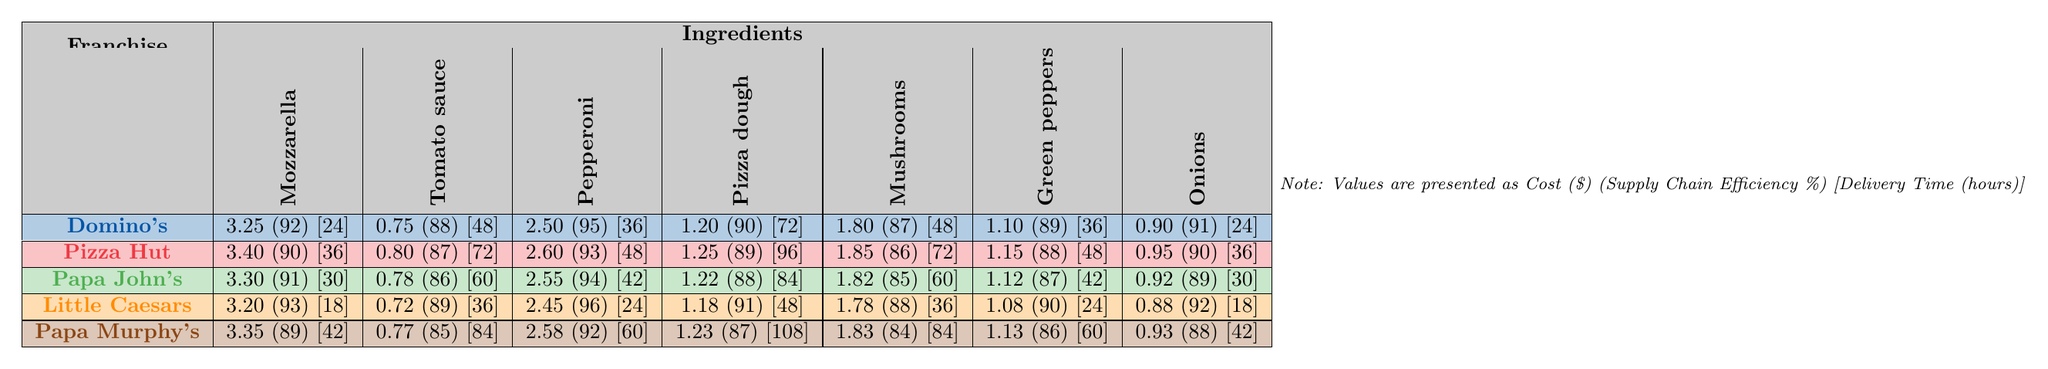What is the cost of mozzarella cheese from Domino's? The table shows the cost of mozzarella cheese for each franchise. For Domino's, the cost is listed as 3.25.
Answer: 3.25 Which franchise has the highest supply chain efficiency for green peppers? The table provides supply chain efficiency percentages for green peppers. Checking the values, Little Caesars has the highest supply chain efficiency at 90%.
Answer: Little Caesars What are the average costs of pizza dough across all franchises? To find the average cost of pizza dough, sum the costs listed (1.20 + 1.25 + 1.22 + 1.18 + 1.23 = 6.08) and divide by the number of franchises (5). Thus, 6.08 / 5 = 1.216.
Answer: 1.216 Is the delivery time for Papa Murphy's shorter than for Papa John's? The delivery times for both franchises can be compared from the table. Papa Murphy's has a delivery time of 42 hours and Papa John's has 30 hours. Since 42 is greater than 30, the statement is false.
Answer: No What is the combined cost of mushrooms and onions from Pizza Hut? From the table, the cost of mushrooms from Pizza Hut is 1.85 and onions is 0.95. Adding these costs together (1.85 + 0.95 = 2.80) gives the combined cost.
Answer: 2.80 Which franchise has the lowest cost for pepperoni? The table indicates that Little Caesars has the lowest cost for pepperoni, priced at 2.45.
Answer: Little Caesars What is the difference in delivery time between the franchise with the shortest and the longest delivery times? Observing the table, the shortest delivery time is 18 hours (Little Caesars) and the longest is 108 hours (Papa Murphy's). The difference is calculated as 108 - 18 = 90 hours.
Answer: 90 Does Domino's have the highest supply chain efficiency for any ingredient? By examining the supply chain efficiency values in the table, Domino's does not have the highest value for any ingredient.
Answer: No What is the average delivery time across all franchises? The delivery times for each franchise are summed (24 + 36 + 30 + 18 + 42 = 150) and then averaged by dividing by 5 franchises (150 / 5 = 30).
Answer: 30 Which ingredient has the highest average cost across all franchises? The costs for each ingredient are averaged, resulting in: Mozzarella (3.304), Tomato sauce (0.754), Pepperoni (2.526), Pizza dough (1.216), Mushrooms (1.819), Green peppers (1.046), Onions (0.892). Thus, mozzarella has the highest average cost.
Answer: Mozzarella cheese 